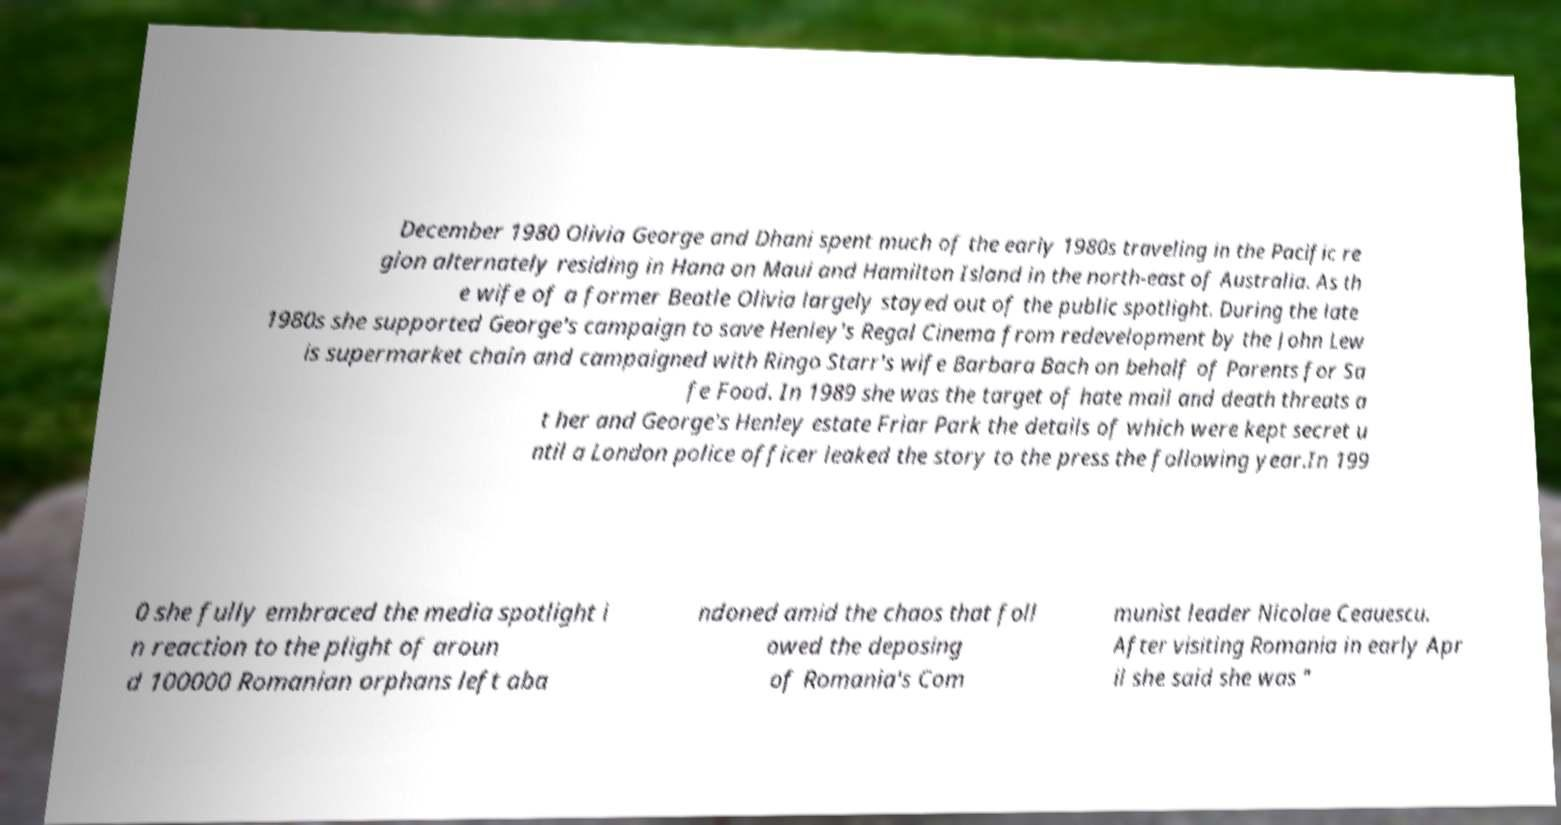Can you accurately transcribe the text from the provided image for me? December 1980 Olivia George and Dhani spent much of the early 1980s traveling in the Pacific re gion alternately residing in Hana on Maui and Hamilton Island in the north-east of Australia. As th e wife of a former Beatle Olivia largely stayed out of the public spotlight. During the late 1980s she supported George's campaign to save Henley's Regal Cinema from redevelopment by the John Lew is supermarket chain and campaigned with Ringo Starr's wife Barbara Bach on behalf of Parents for Sa fe Food. In 1989 she was the target of hate mail and death threats a t her and George's Henley estate Friar Park the details of which were kept secret u ntil a London police officer leaked the story to the press the following year.In 199 0 she fully embraced the media spotlight i n reaction to the plight of aroun d 100000 Romanian orphans left aba ndoned amid the chaos that foll owed the deposing of Romania's Com munist leader Nicolae Ceauescu. After visiting Romania in early Apr il she said she was " 